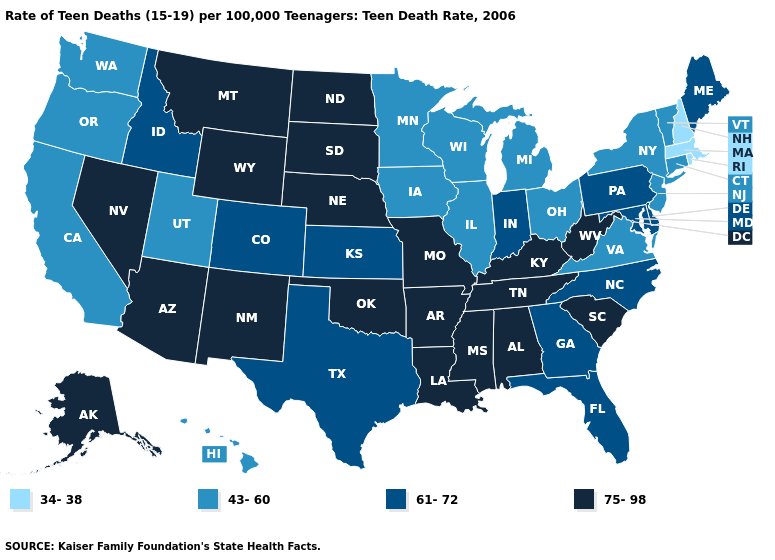Name the states that have a value in the range 34-38?
Write a very short answer. Massachusetts, New Hampshire, Rhode Island. What is the value of Tennessee?
Be succinct. 75-98. Does the map have missing data?
Short answer required. No. What is the value of Alabama?
Short answer required. 75-98. Name the states that have a value in the range 75-98?
Answer briefly. Alabama, Alaska, Arizona, Arkansas, Kentucky, Louisiana, Mississippi, Missouri, Montana, Nebraska, Nevada, New Mexico, North Dakota, Oklahoma, South Carolina, South Dakota, Tennessee, West Virginia, Wyoming. Name the states that have a value in the range 61-72?
Short answer required. Colorado, Delaware, Florida, Georgia, Idaho, Indiana, Kansas, Maine, Maryland, North Carolina, Pennsylvania, Texas. Among the states that border New Mexico , does Utah have the lowest value?
Short answer required. Yes. Name the states that have a value in the range 75-98?
Write a very short answer. Alabama, Alaska, Arizona, Arkansas, Kentucky, Louisiana, Mississippi, Missouri, Montana, Nebraska, Nevada, New Mexico, North Dakota, Oklahoma, South Carolina, South Dakota, Tennessee, West Virginia, Wyoming. Name the states that have a value in the range 34-38?
Be succinct. Massachusetts, New Hampshire, Rhode Island. What is the value of Kansas?
Short answer required. 61-72. Name the states that have a value in the range 43-60?
Give a very brief answer. California, Connecticut, Hawaii, Illinois, Iowa, Michigan, Minnesota, New Jersey, New York, Ohio, Oregon, Utah, Vermont, Virginia, Washington, Wisconsin. What is the value of Kansas?
Short answer required. 61-72. Is the legend a continuous bar?
Short answer required. No. Does the map have missing data?
Write a very short answer. No. Name the states that have a value in the range 34-38?
Keep it brief. Massachusetts, New Hampshire, Rhode Island. 